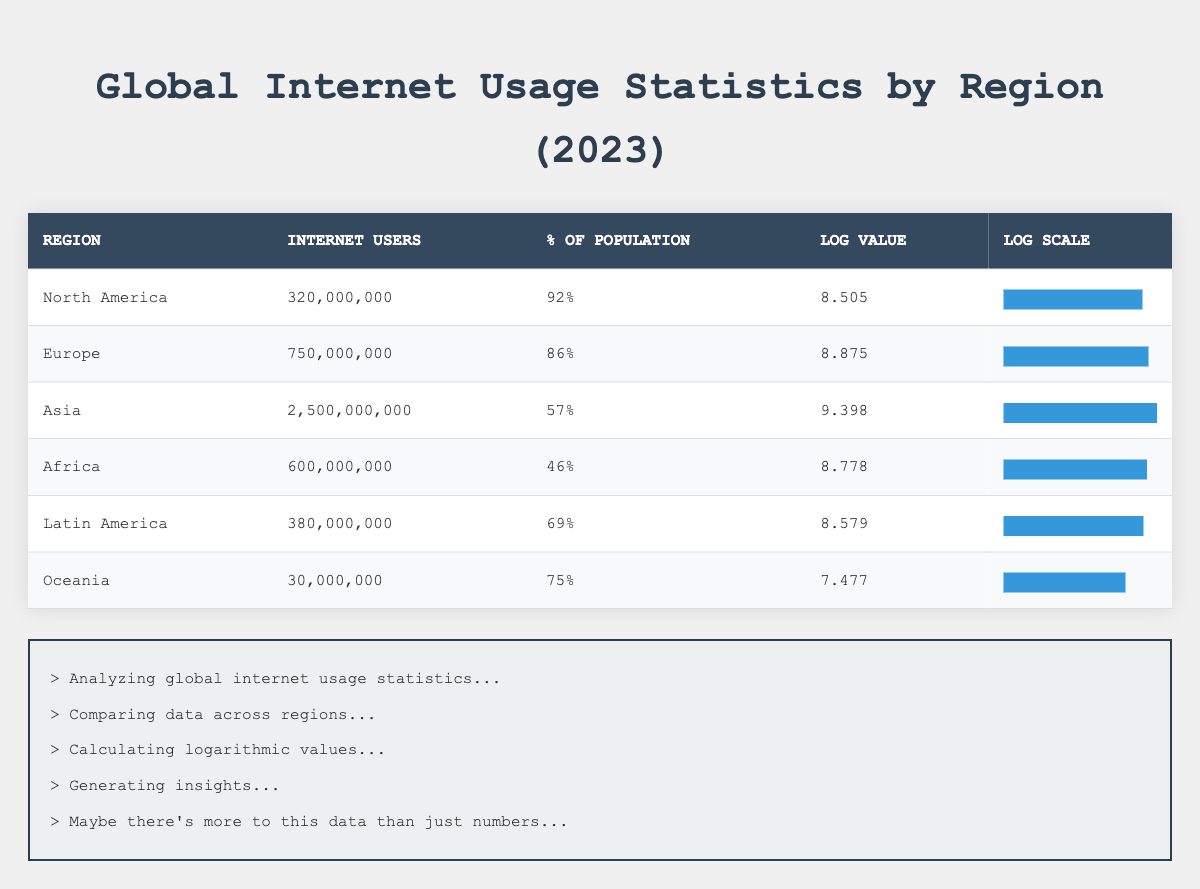What is the percentage of the population using the internet in Africa? According to the table, Africa has an internet usage percentage of 46% of its population. This value is directly listed under the "% of Population" column for Africa.
Answer: 46% Which region has the highest number of internet users? The table shows that Asia has 2,500,000,000 internet users, which is the highest number compared to all other regions. This total can be found under the "Internet Users" column for Asia.
Answer: Asia What is the average percentage of population using the internet across all regions? To find the average percentage, we sum the percentages: 92 + 86 + 57 + 46 + 69 + 75 = 425. Then, we divide by the number of regions (6): 425 / 6 = approximately 70.83.
Answer: Approximately 70.83% Is it true that North America has a higher percentage of its population using the internet than Africa? Yes, North America has an internet usage percentage of 92%, while Africa has a percentage of 46%. Comparing these two values confirms that North America has a higher percentage.
Answer: Yes Which region has the lowest logarithmic value indicating internet users? By examining the "Log Value" column, we see that Oceania has the lowest value of 7.477, compared to the other regions. This value is directly listed in the table for Oceania.
Answer: Oceania How many more internet users does Europe have than Latin America? According to the table, Europe has 750,000,000 internet users and Latin America has 380,000,000. The difference can be calculated as: 750,000,000 - 380,000,000 = 370,000,000.
Answer: 370,000,000 Are there more internet users in North America or Africa? North America has 320,000,000 internet users, while Africa has 600,000,000. Therefore, when comparing both, there are more users in Africa.
Answer: No What is the total number of internet users across all regions? To find the total, we add the internet users from each region: 320,000,000 + 750,000,000 + 2,500,000,000 + 600,000,000 + 380,000,000 + 30,000,000 = 4,580,000,000. Thus, the total number is found through summation.
Answer: 4,580,000,000 Which regions have a percentage of population above 75%? By reviewing the "% of Population" column, we see that North America (92%) and Europe (86%) have percentages above 75%. This comparison shows both exceed the threshold.
Answer: North America and Europe 